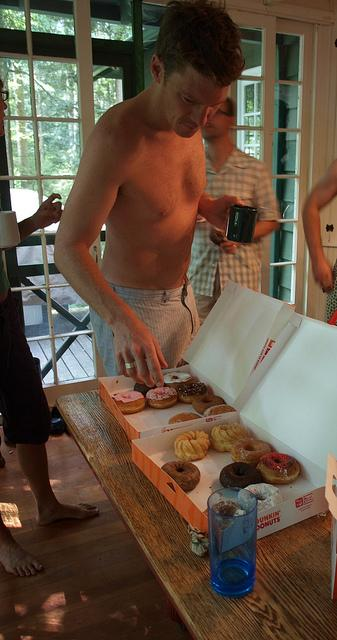What is the donut called that has ridges down the sides? Please explain your reasoning. cruller. A ridged donut is called a cruller. 